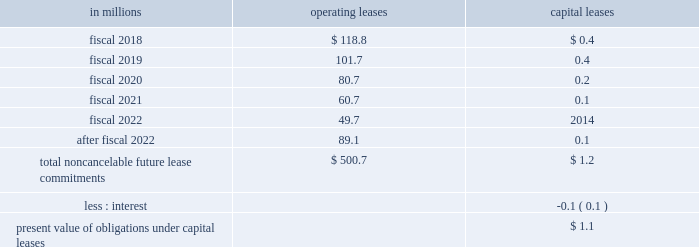Able to reasonably estimate the timing of future cash flows beyond 12 months due to uncertainties in the timing of tax audit outcomes .
The remaining amount of our unrecognized tax liability was classified in other liabilities .
We report accrued interest and penalties related to unrecognized tax benefit liabilities in income tax expense .
For fiscal 2017 , we recognized a net benefit of $ 5.6 million of tax-related net interest and penalties , and had $ 23.1 million of accrued interest and penalties as of may 28 , 2017 .
For fiscal 2016 , we recognized a net benefit of $ 2.7 million of tax-related net interest and penalties , and had $ 32.1 million of accrued interest and penalties as of may 29 , 2016 .
Note 15 .
Leases , other commitments , and contingencies the company 2019s leases are generally for warehouse space and equipment .
Rent expense under all operating leases from continuing operations was $ 188.1 million in fiscal 2017 , $ 189.1 million in fiscal 2016 , and $ 193.5 million in fiscal 2015 .
Some operating leases require payment of property taxes , insurance , and maintenance costs in addition to the rent payments .
Contingent and escalation rent in excess of minimum rent payments and sublease income netted in rent expense were insignificant .
Noncancelable future lease commitments are : operating capital in millions leases leases .
Depreciation on capital leases is recorded as deprecia- tion expense in our results of operations .
As of may 28 , 2017 , we have issued guarantees and comfort letters of $ 504.7 million for the debt and other obligations of consolidated subsidiaries , and guarantees and comfort letters of $ 165.3 million for the debt and other obligations of non-consolidated affiliates , mainly cpw .
In addition , off-balance sheet arrangements are generally limited to the future payments under non-cancelable operating leases , which totaled $ 500.7 million as of may 28 , 2017 .
Note 16 .
Business segment and geographic information we operate in the consumer foods industry .
In the third quarter of fiscal 2017 , we announced a new global orga- nization structure to streamline our leadership , enhance global scale , and drive improved operational agility to maximize our growth capabilities .
As a result of this global reorganization , beginning in the third quarter of fiscal 2017 , we reported results for our four operating segments as follows : north america retail , 65.3 percent of our fiscal 2017 consolidated net sales ; convenience stores & foodservice , 12.0 percent of our fiscal 2017 consolidated net sales ; europe & australia , 11.7 percent of our fiscal 2017 consolidated net sales ; and asia & latin america , 11.0 percent of our fiscal 2017 consoli- dated net sales .
We have restated our net sales by seg- ment and segment operating profit amounts to reflect our new operating segments .
These segment changes had no effect on previously reported consolidated net sales , operating profit , net earnings attributable to general mills , or earnings per share .
Our north america retail operating segment consists of our former u.s .
Retail operating units and our canada region .
Within our north america retail operating seg- ment , our former u.s .
Meals operating unit and u.s .
Baking operating unit have been combined into one operating unit : u.s .
Meals & baking .
Our convenience stores & foodservice operating segment is unchanged .
Our europe & australia operating segment consists of our former europe region .
Our asia & latin america operating segment consists of our former asia/pacific and latin america regions .
Under our new organization structure , our chief operating decision maker assesses performance and makes decisions about resources to be allocated to our segments at the north america retail , convenience stores & foodservice , europe & australia , and asia & latin america operating segment level .
Our north america retail operating segment reflects business with a wide variety of grocery stores , mass merchandisers , membership stores , natural food chains , drug , dollar and discount chains , and e-commerce gro- cery providers .
Our product categories in this business 84 general mills .
What will be the percentage decrease in operating leases from 2017 to 2018? 
Computations: ((118.8 - 188.1) / 188.1)
Answer: -0.36842. 